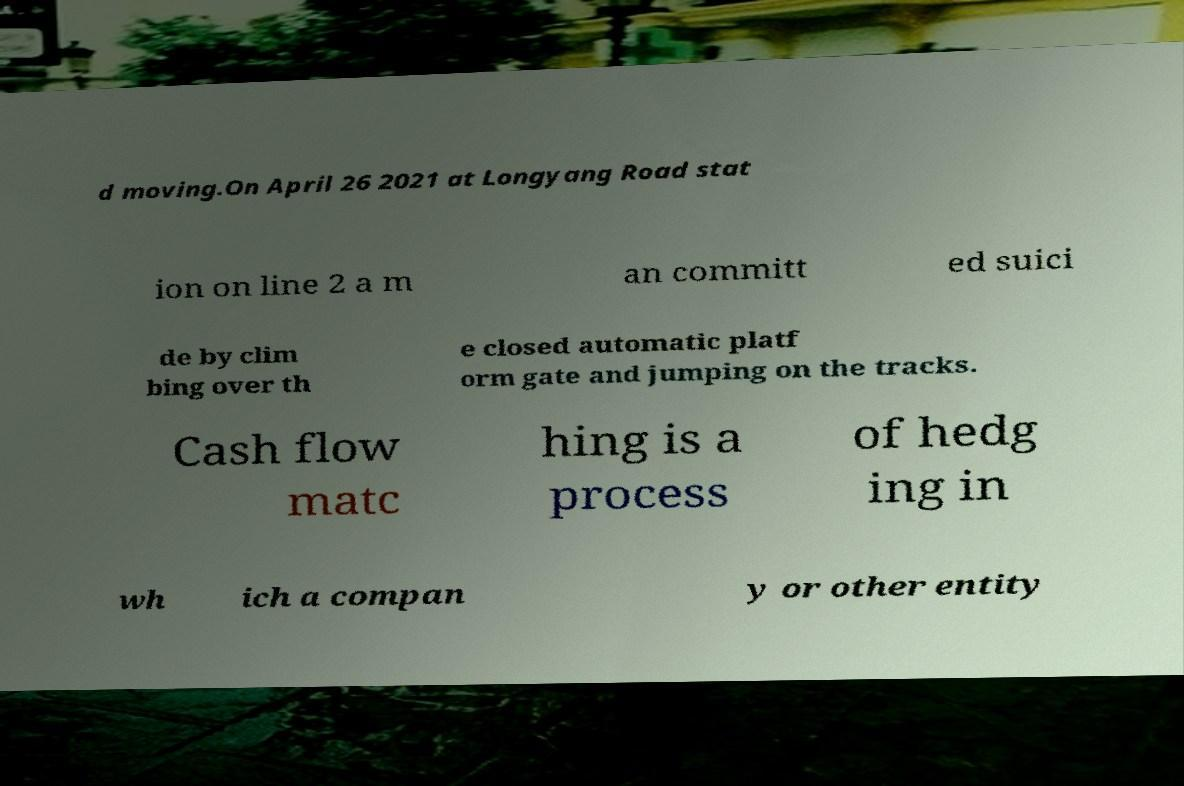Please identify and transcribe the text found in this image. d moving.On April 26 2021 at Longyang Road stat ion on line 2 a m an committ ed suici de by clim bing over th e closed automatic platf orm gate and jumping on the tracks. Cash flow matc hing is a process of hedg ing in wh ich a compan y or other entity 